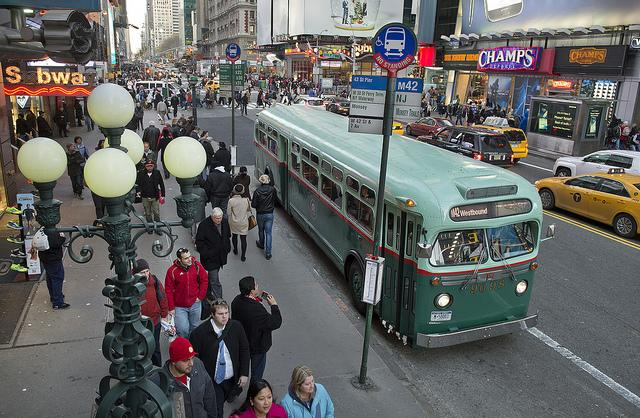Why are only the letters SBwa visible on that sign? lights out 